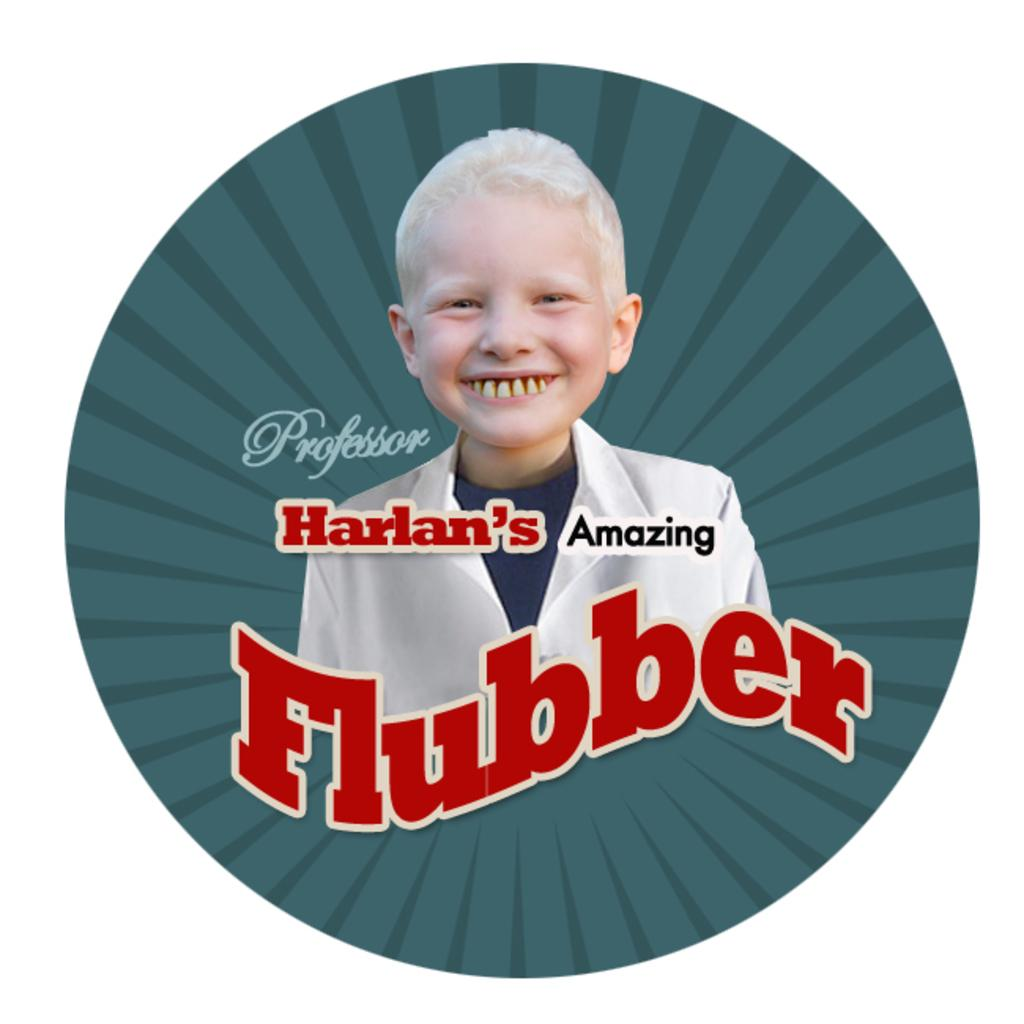What type of visual is the image? The image is a poster. What is the main subject of the poster? There is a kid in the center of the poster. How is the kid depicted in the poster? The kid is smiling. What else can be seen on the poster besides the kid? There is text on the poster. What color is the background of the poster? The poster has a green background. Can you see a ghost interacting with the kid in the poster? No, there is no ghost present in the poster. What type of apple is being held by the kid in the poster? There is no apple visible in the poster; the main subject is a kid with a smiling expression. 